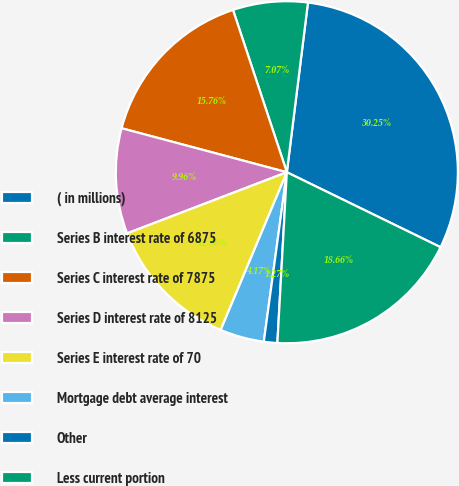Convert chart to OTSL. <chart><loc_0><loc_0><loc_500><loc_500><pie_chart><fcel>( in millions)<fcel>Series B interest rate of 6875<fcel>Series C interest rate of 7875<fcel>Series D interest rate of 8125<fcel>Series E interest rate of 70<fcel>Mortgage debt average interest<fcel>Other<fcel>Less current portion<nl><fcel>30.25%<fcel>7.07%<fcel>15.76%<fcel>9.96%<fcel>12.86%<fcel>4.17%<fcel>1.27%<fcel>18.66%<nl></chart> 